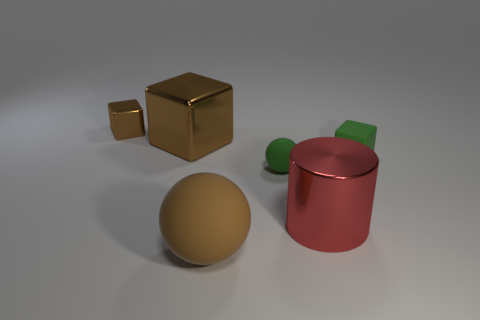Add 2 green rubber things. How many objects exist? 8 Subtract all cylinders. How many objects are left? 5 Add 3 large shiny objects. How many large shiny objects are left? 5 Add 4 red cylinders. How many red cylinders exist? 5 Subtract 1 green spheres. How many objects are left? 5 Subtract all rubber spheres. Subtract all small cubes. How many objects are left? 2 